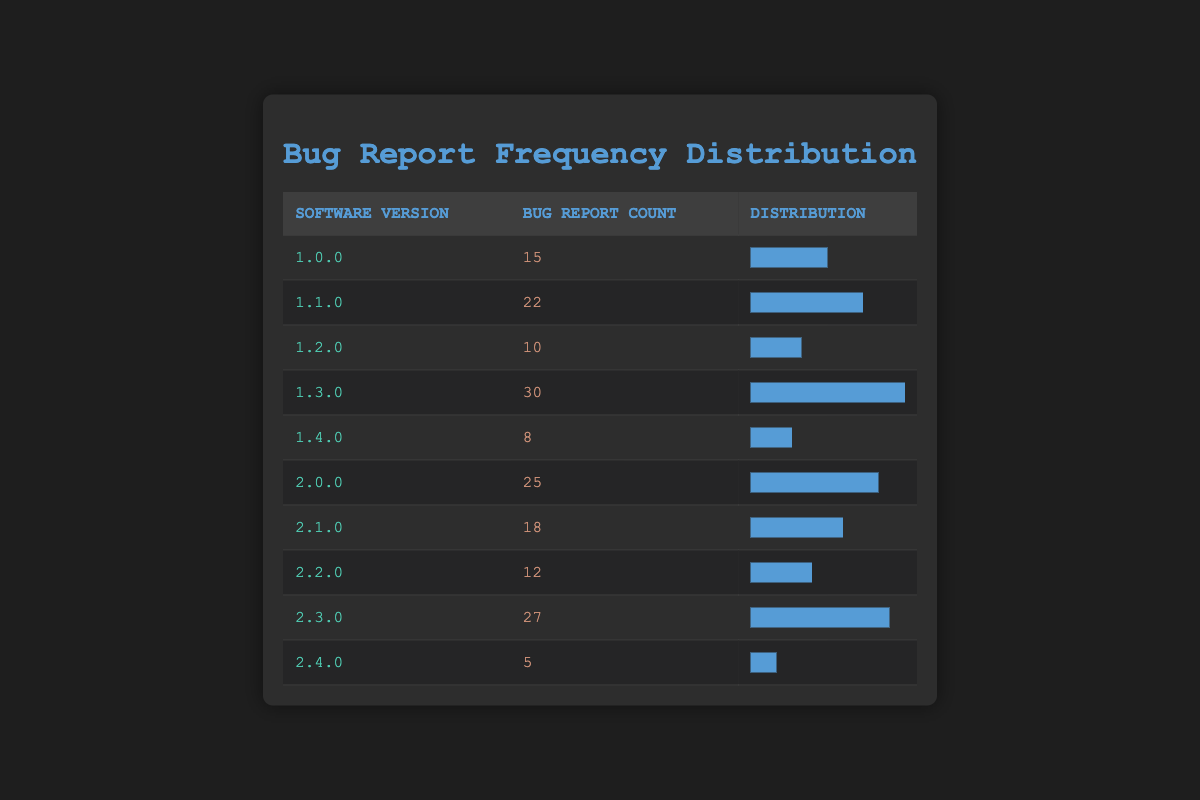What is the version with the highest number of bug reports? By reviewing the bug report counts for each version, I can see that version 1.3.0 has the highest count at 30 reports.
Answer: 1.3.0 How many bug reports were filed for version 2.4.0? Version 2.4.0 has a bug report count of 5, as indicated in the table.
Answer: 5 What is the total number of bug reports across all versions? To find the total, I add the bug report counts for all versions: 15 + 22 + 10 + 30 + 8 + 25 + 18 + 12 + 27 + 5 =  172.
Answer: 172 Which version has a bug report count that is lower than the average of all versions? First, I calculate the average by dividing the total number of reports (172) by the number of versions (10). This gives me an average of 17.2. Next, I see that versions 1.2.0, 1.4.0, and 2.4.0 have counts lower than 17.2 (10, 8, and 5, respectively).
Answer: 1.2.0, 1.4.0, 2.4.0 Is it true that version 2.1.0 has fewer bug reports than version 1.1.0? Checking the counts, version 2.1.0 has 18 reports, while version 1.1.0 has 22. Since 18 is less than 22, the statement is true.
Answer: Yes What is the difference in bug report counts between version 1.3.0 and version 2.3.0? Version 1.3.0 has 30 reports and version 2.3.0 has 27. The difference is calculated as 30 - 27 = 3.
Answer: 3 Which version represents the lowest percentage of bug reports relative to the highest one? The highest count is for version 1.3.0 with 30 reports, and the lowest is for version 2.4.0 with 5 reports. The percentage is (5/30)*100 = 16.67%.
Answer: 16.67% Are there any versions with bug report counts equal to 20? Looking through the table, I see that there is no version with a count of 20; hence, the answer is no.
Answer: No How many versions have bug report counts greater than 15? The versions with counts greater than 15 are 1.1.0, 1.3.0, 2.0.0, 2.1.0, 2.3.0, making a total of 5 versions.
Answer: 5 